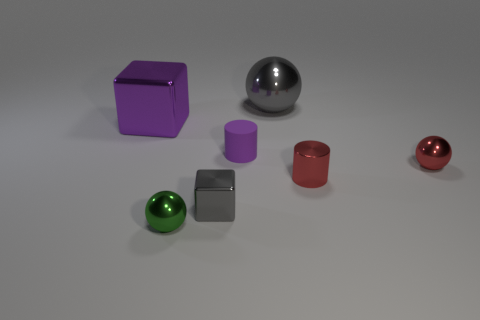Subtract all small red metallic spheres. How many spheres are left? 2 Subtract all gray spheres. How many spheres are left? 2 Add 4 tiny matte things. How many tiny matte things exist? 5 Add 1 big metal objects. How many objects exist? 8 Subtract 1 green balls. How many objects are left? 6 Subtract all cubes. How many objects are left? 5 Subtract 1 blocks. How many blocks are left? 1 Subtract all gray cylinders. Subtract all cyan spheres. How many cylinders are left? 2 Subtract all brown balls. How many gray cubes are left? 1 Subtract all big purple shiny objects. Subtract all large gray spheres. How many objects are left? 5 